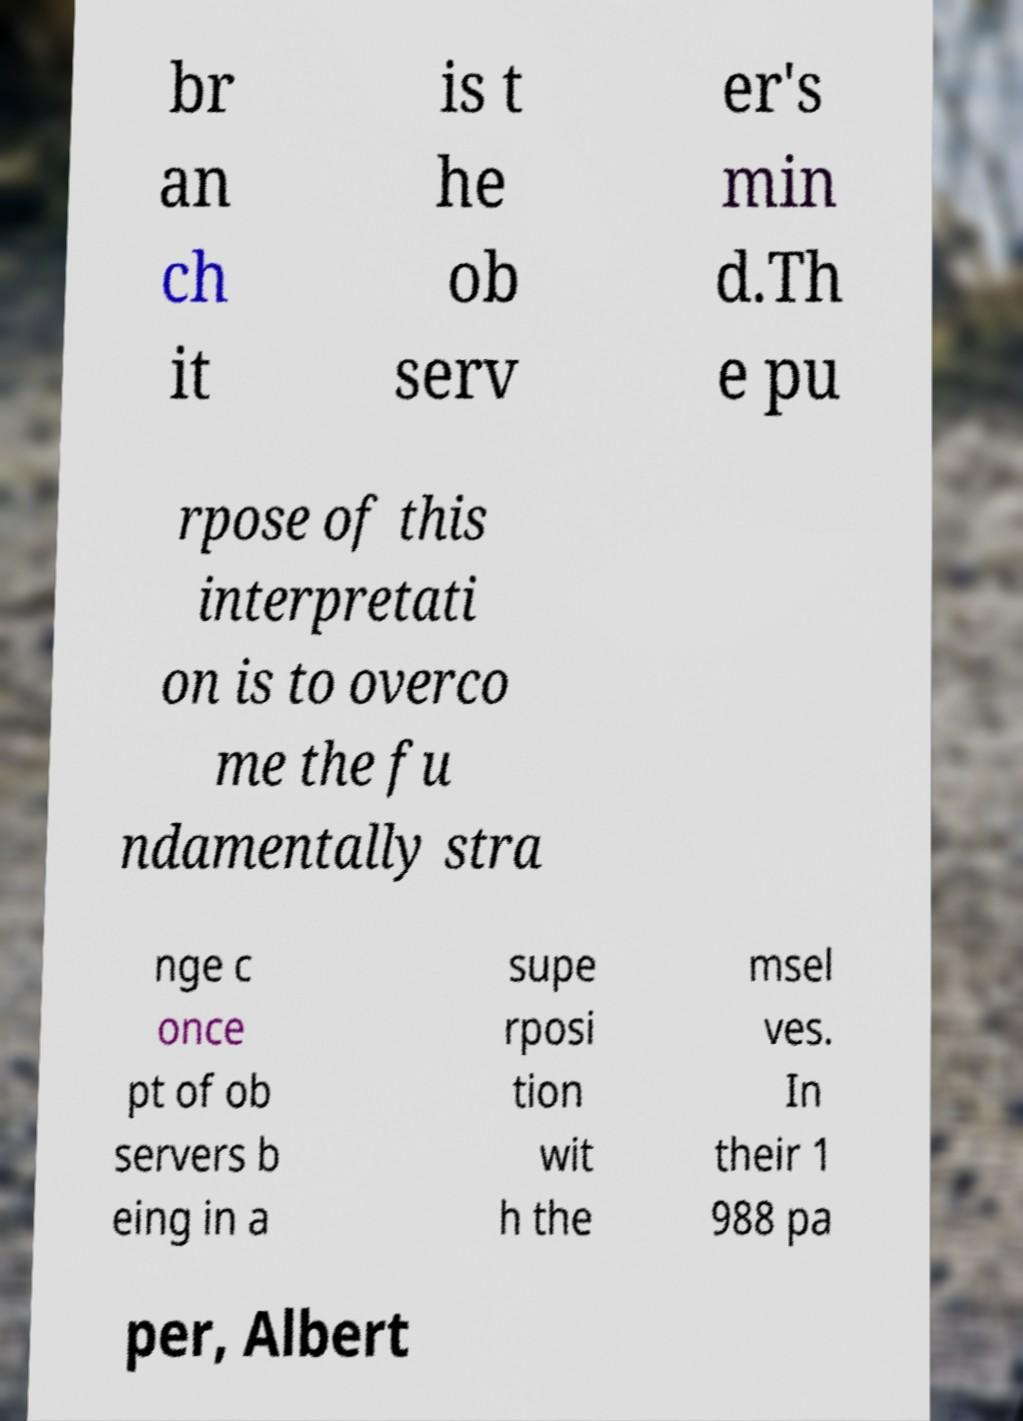Could you extract and type out the text from this image? br an ch it is t he ob serv er's min d.Th e pu rpose of this interpretati on is to overco me the fu ndamentally stra nge c once pt of ob servers b eing in a supe rposi tion wit h the msel ves. In their 1 988 pa per, Albert 